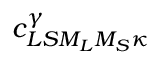Convert formula to latex. <formula><loc_0><loc_0><loc_500><loc_500>{ c } _ { L S { M } _ { L } { M } _ { S } \kappa } ^ { \gamma }</formula> 